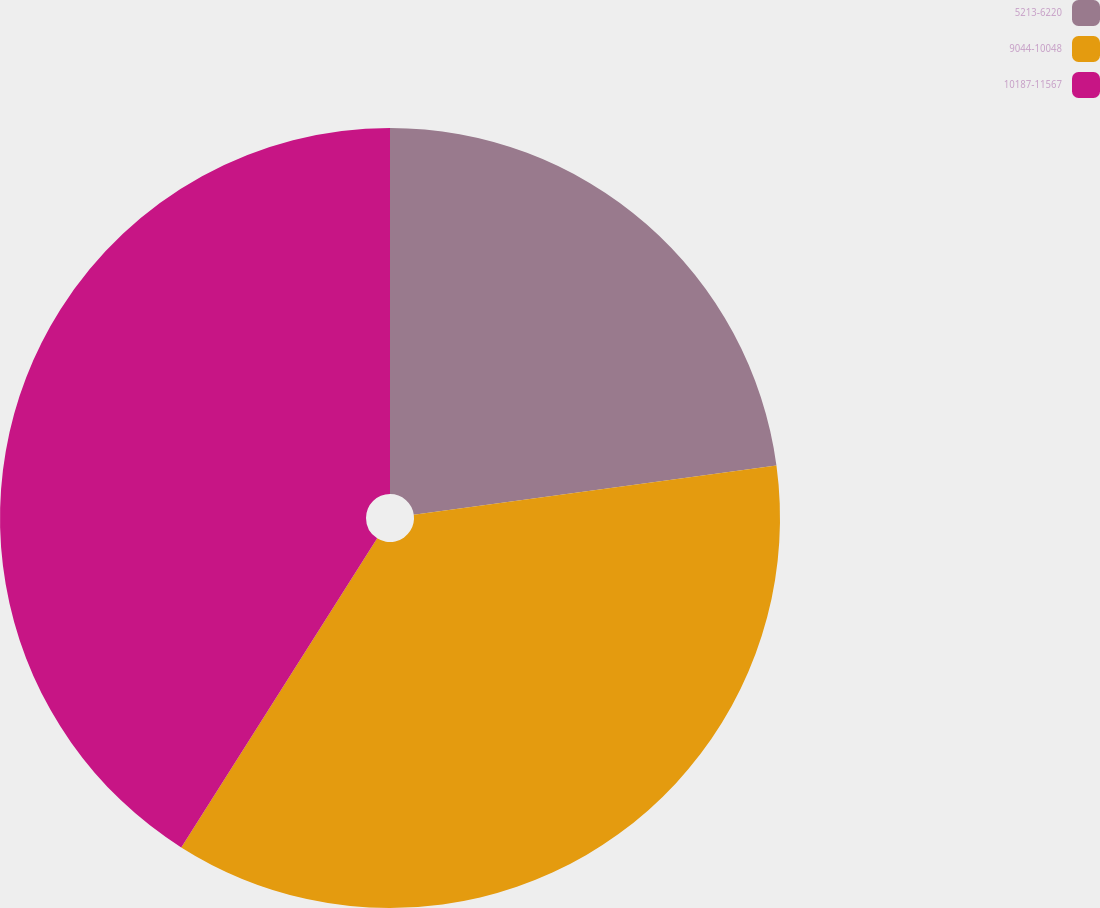<chart> <loc_0><loc_0><loc_500><loc_500><pie_chart><fcel>5213-6220<fcel>9044-10048<fcel>10187-11567<nl><fcel>22.85%<fcel>36.14%<fcel>41.01%<nl></chart> 